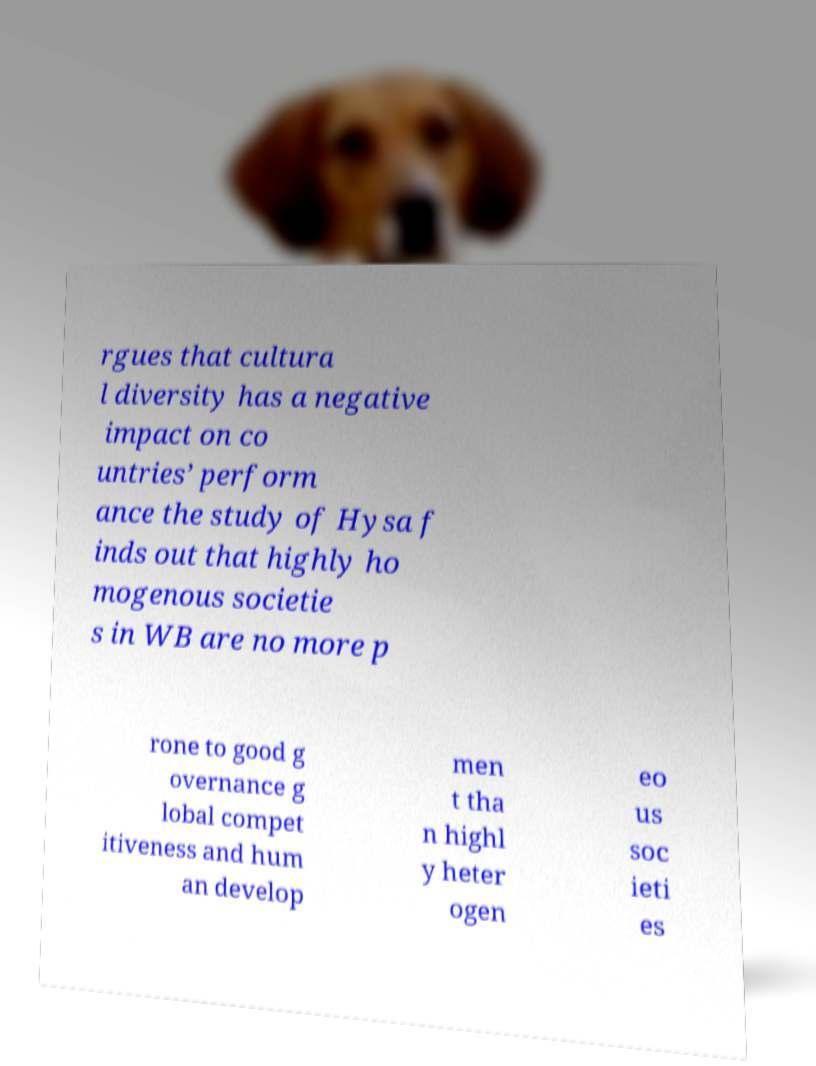Could you extract and type out the text from this image? rgues that cultura l diversity has a negative impact on co untries’ perform ance the study of Hysa f inds out that highly ho mogenous societie s in WB are no more p rone to good g overnance g lobal compet itiveness and hum an develop men t tha n highl y heter ogen eo us soc ieti es 